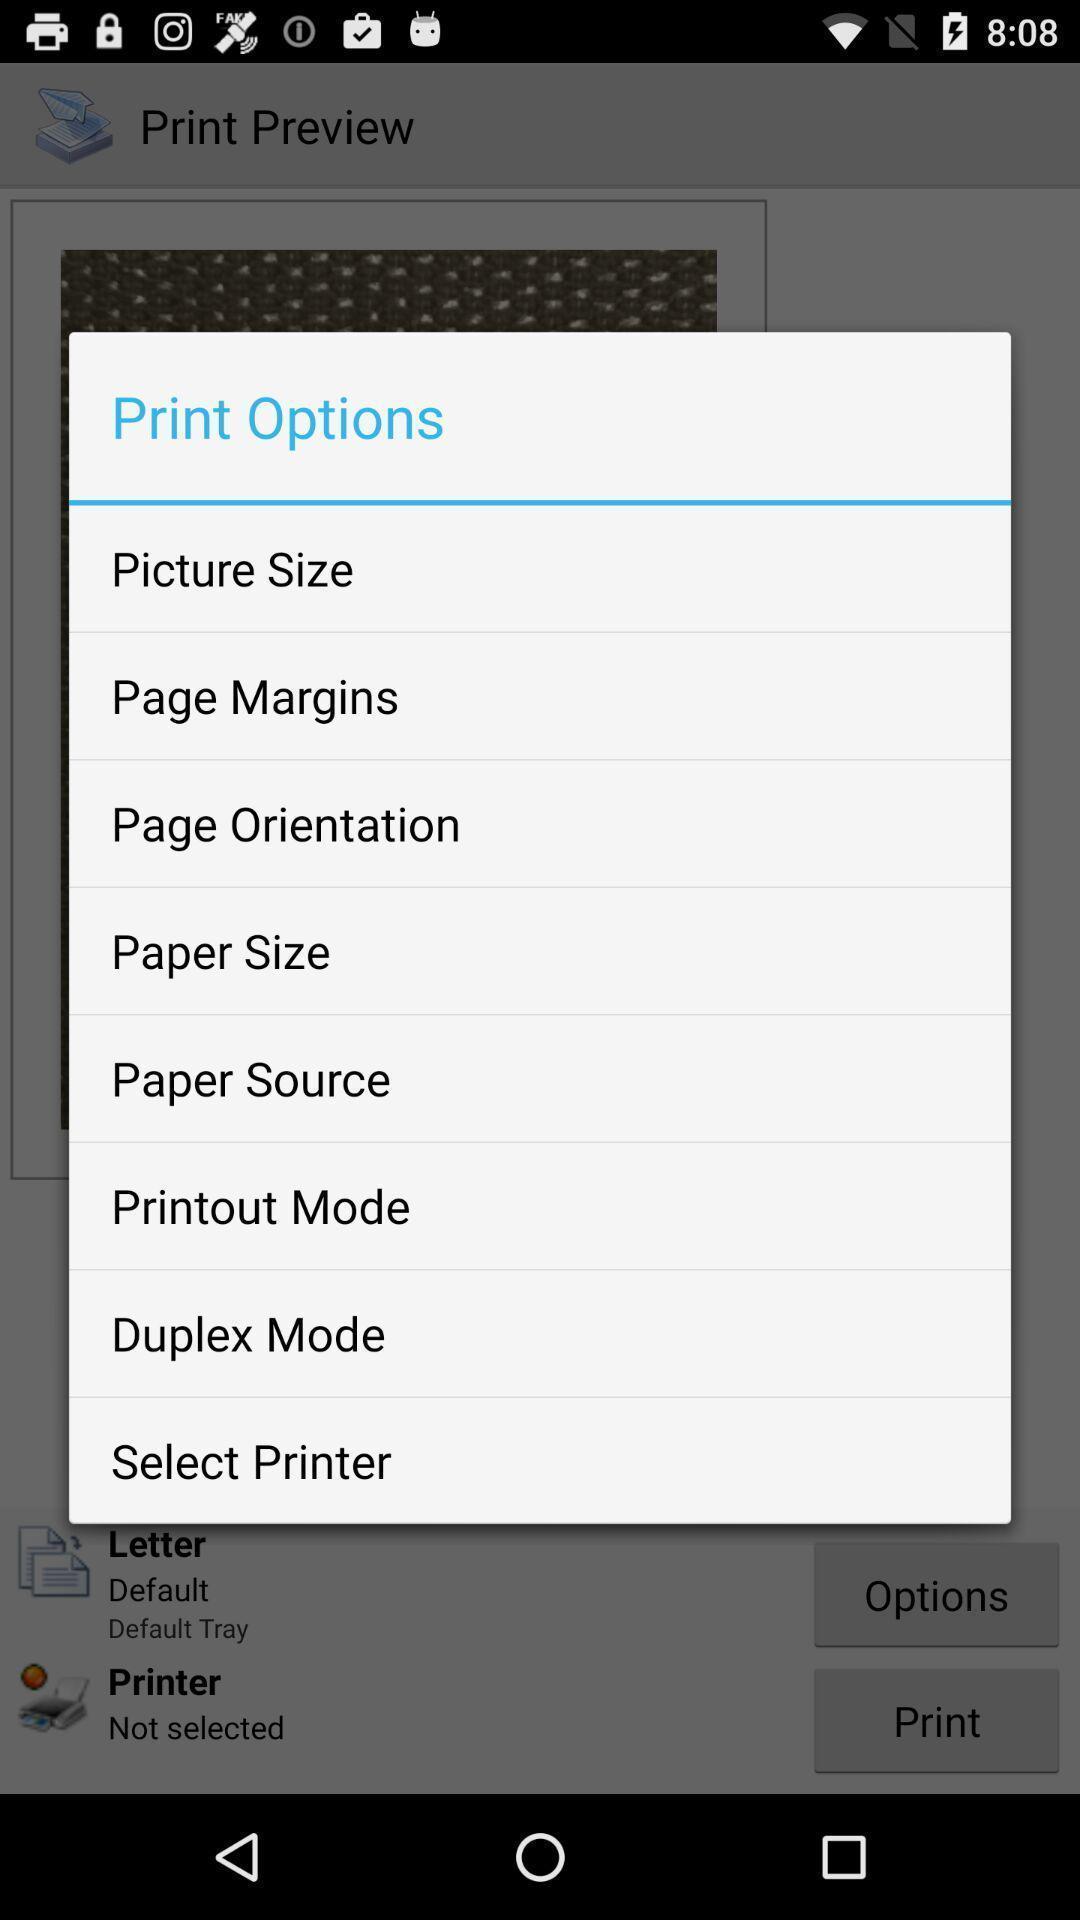Tell me about the visual elements in this screen capture. Popup showing options to select. 